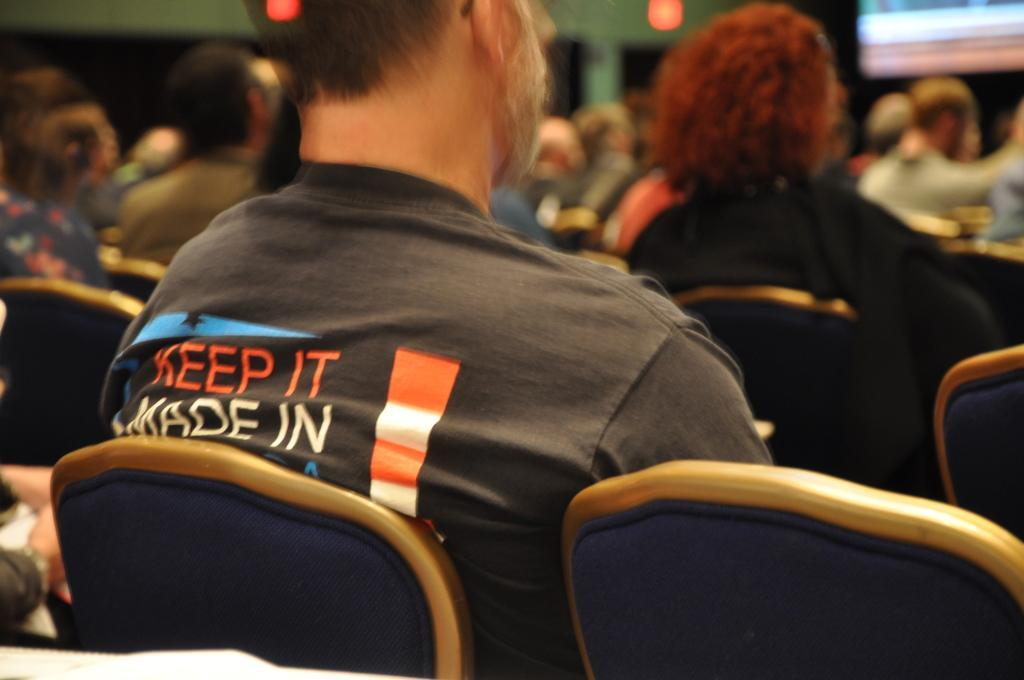What are the people in the image doing? There are persons sitting on chairs in the image. What can be seen behind the people? There is a wall in the image. Is there any entrance or exit visible in the image? Yes, there is a door in the image. What else can be seen in the background of the image? There is a partial part of a screen visible in the background, and there appears to be a light in the background. Where is the sink located in the image? There is no sink present in the image. What type of spring is visible in the image? There is no spring present in the image. 